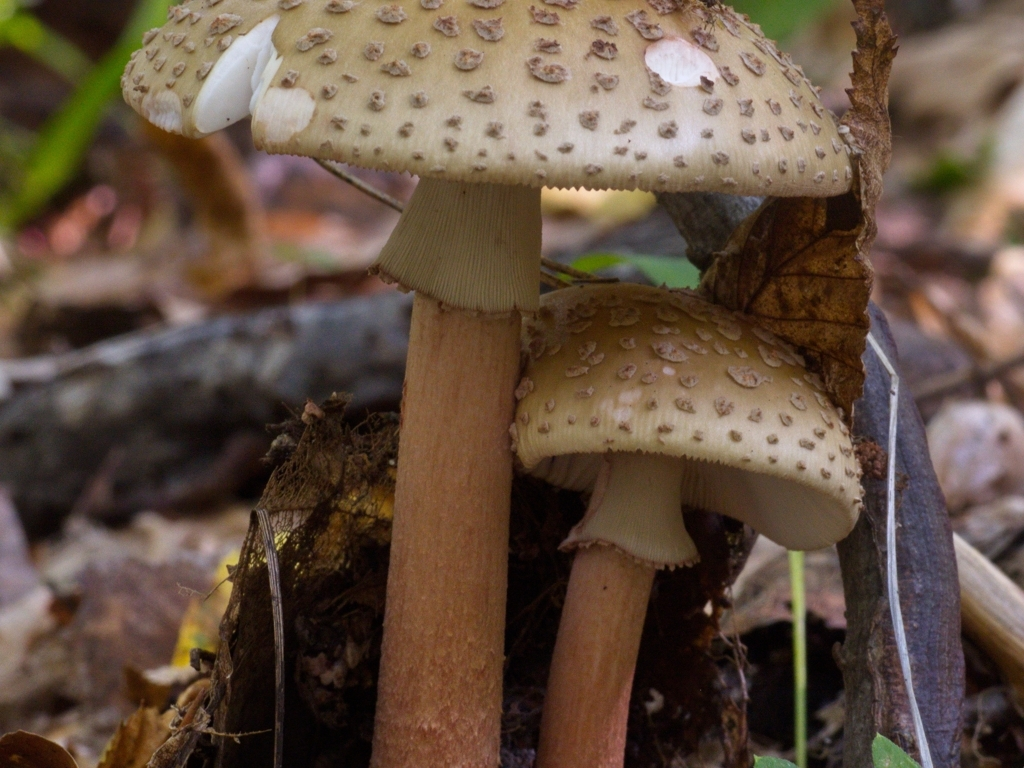What is the focus of the image? The focus of the image is prominently on the mushrooms in the foreground. Their distinctive brown caps dotted with lighter scales and gills underneath are crisply captured, drawing the viewer's attention immediately. The soft bokeh effect subtly blurs the background, ensuring that while the surrounding foliage and potential hints of flowers do add context, they don't distract from the mushrooms as the main subject. 